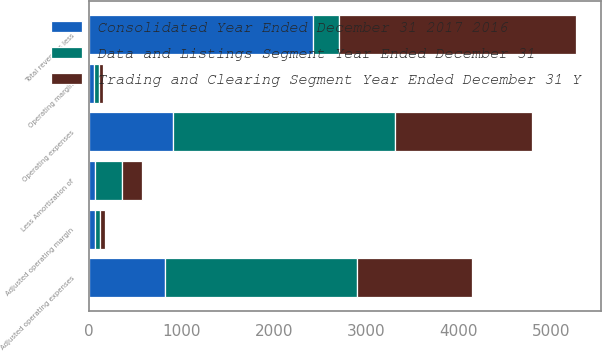Convert chart to OTSL. <chart><loc_0><loc_0><loc_500><loc_500><stacked_bar_chart><ecel><fcel>Total revenues less<fcel>Operating expenses<fcel>Less Amortization of<fcel>Adjusted operating expenses<fcel>Operating margin<fcel>Adjusted operating margin<nl><fcel>Consolidated Year Ended December 31 2017 2016<fcel>2420<fcel>911<fcel>73<fcel>824<fcel>62<fcel>66<nl><fcel>Trading and Clearing Segment Year Ended December 31 Y<fcel>2559<fcel>1485<fcel>214<fcel>1247<fcel>42<fcel>51<nl><fcel>Data and Listings Segment Year Ended December 31<fcel>287<fcel>2396<fcel>287<fcel>2071<fcel>52<fcel>58<nl></chart> 